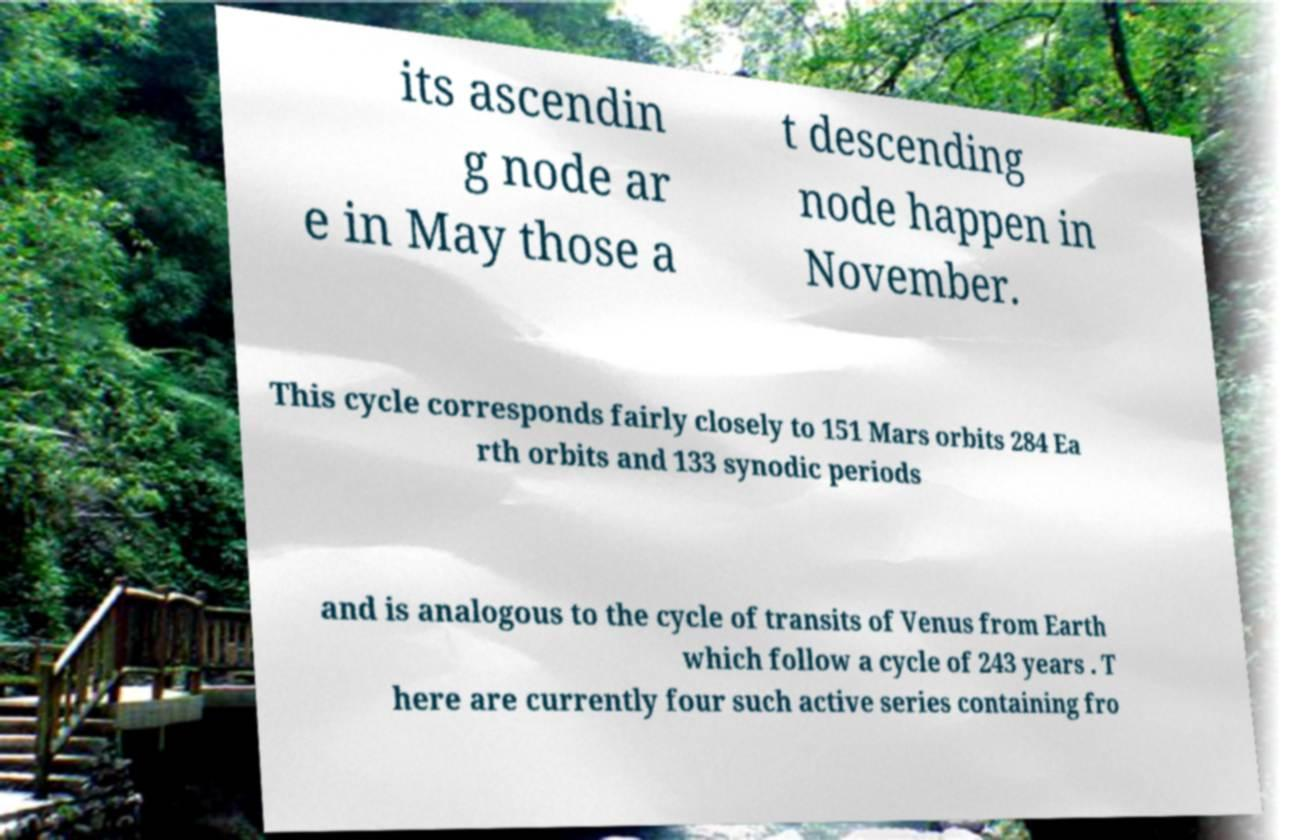Could you assist in decoding the text presented in this image and type it out clearly? its ascendin g node ar e in May those a t descending node happen in November. This cycle corresponds fairly closely to 151 Mars orbits 284 Ea rth orbits and 133 synodic periods and is analogous to the cycle of transits of Venus from Earth which follow a cycle of 243 years . T here are currently four such active series containing fro 